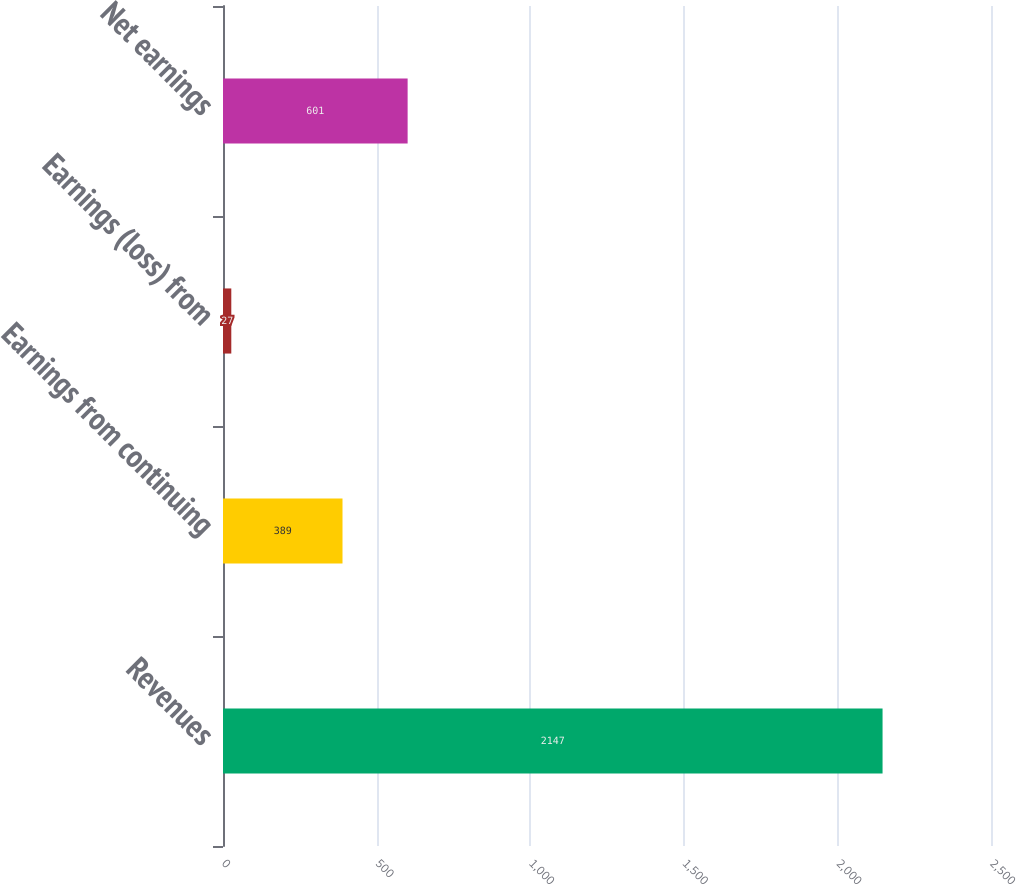Convert chart. <chart><loc_0><loc_0><loc_500><loc_500><bar_chart><fcel>Revenues<fcel>Earnings from continuing<fcel>Earnings (loss) from<fcel>Net earnings<nl><fcel>2147<fcel>389<fcel>27<fcel>601<nl></chart> 